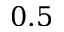Convert formula to latex. <formula><loc_0><loc_0><loc_500><loc_500>0 . 5</formula> 